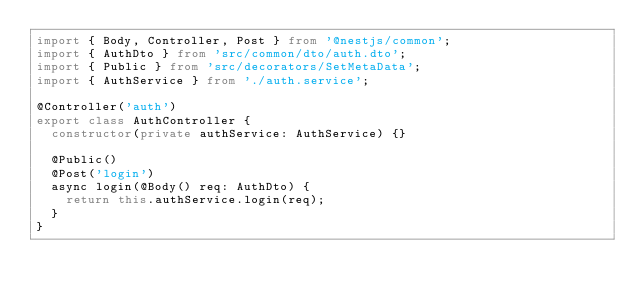Convert code to text. <code><loc_0><loc_0><loc_500><loc_500><_TypeScript_>import { Body, Controller, Post } from '@nestjs/common';
import { AuthDto } from 'src/common/dto/auth.dto';
import { Public } from 'src/decorators/SetMetaData';
import { AuthService } from './auth.service';

@Controller('auth')
export class AuthController {
  constructor(private authService: AuthService) {}

  @Public()
  @Post('login')
  async login(@Body() req: AuthDto) {
    return this.authService.login(req);
  }
}
</code> 